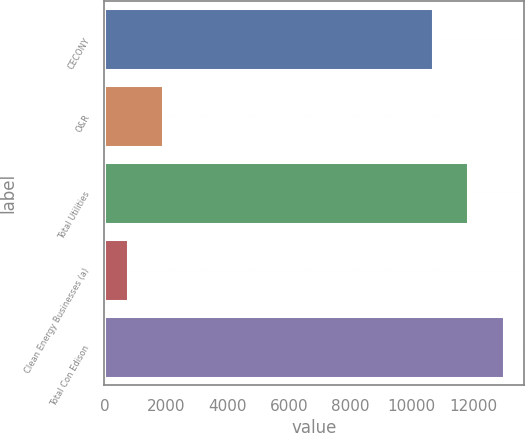Convert chart to OTSL. <chart><loc_0><loc_0><loc_500><loc_500><bar_chart><fcel>CECONY<fcel>O&R<fcel>Total Utilities<fcel>Clean Energy Businesses (a)<fcel>Total Con Edison<nl><fcel>10680<fcel>1920.4<fcel>11837.4<fcel>763<fcel>12994.8<nl></chart> 